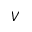Convert formula to latex. <formula><loc_0><loc_0><loc_500><loc_500>V</formula> 